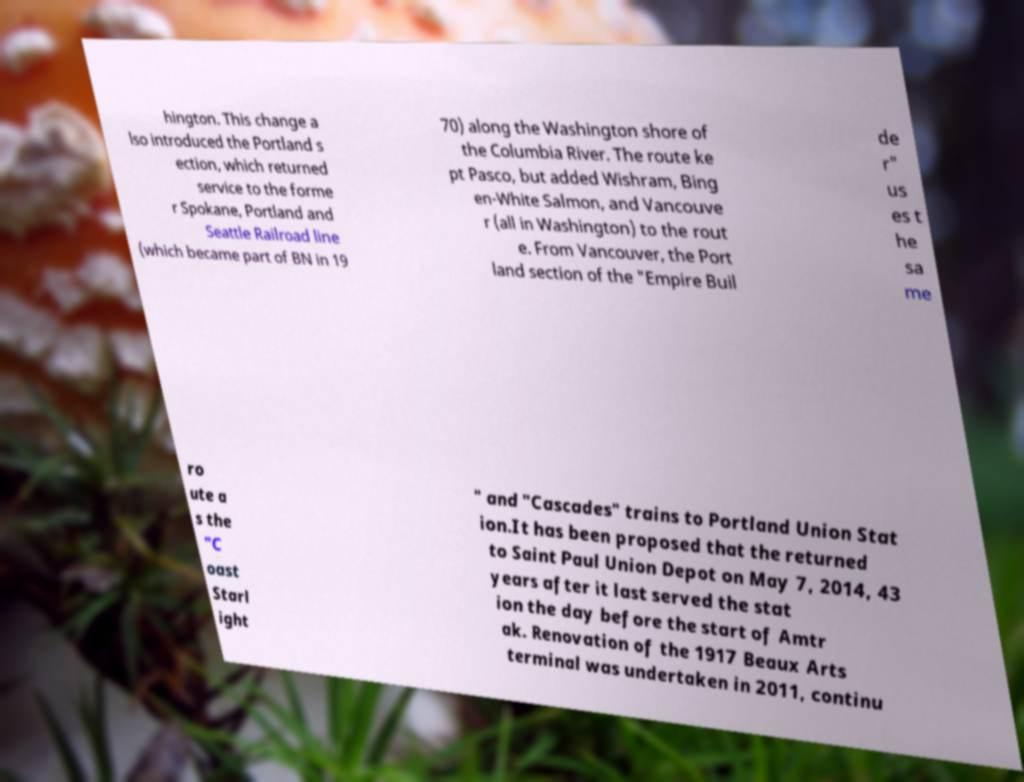Can you accurately transcribe the text from the provided image for me? hington. This change a lso introduced the Portland s ection, which returned service to the forme r Spokane, Portland and Seattle Railroad line (which became part of BN in 19 70) along the Washington shore of the Columbia River. The route ke pt Pasco, but added Wishram, Bing en-White Salmon, and Vancouve r (all in Washington) to the rout e. From Vancouver, the Port land section of the "Empire Buil de r" us es t he sa me ro ute a s the "C oast Starl ight " and "Cascades" trains to Portland Union Stat ion.It has been proposed that the returned to Saint Paul Union Depot on May 7, 2014, 43 years after it last served the stat ion the day before the start of Amtr ak. Renovation of the 1917 Beaux Arts terminal was undertaken in 2011, continu 